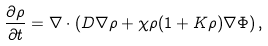Convert formula to latex. <formula><loc_0><loc_0><loc_500><loc_500>\frac { \partial \rho } { \partial t } = \nabla \cdot \left ( D \nabla \rho + \chi \rho ( 1 + K \rho ) \nabla \Phi \right ) ,</formula> 